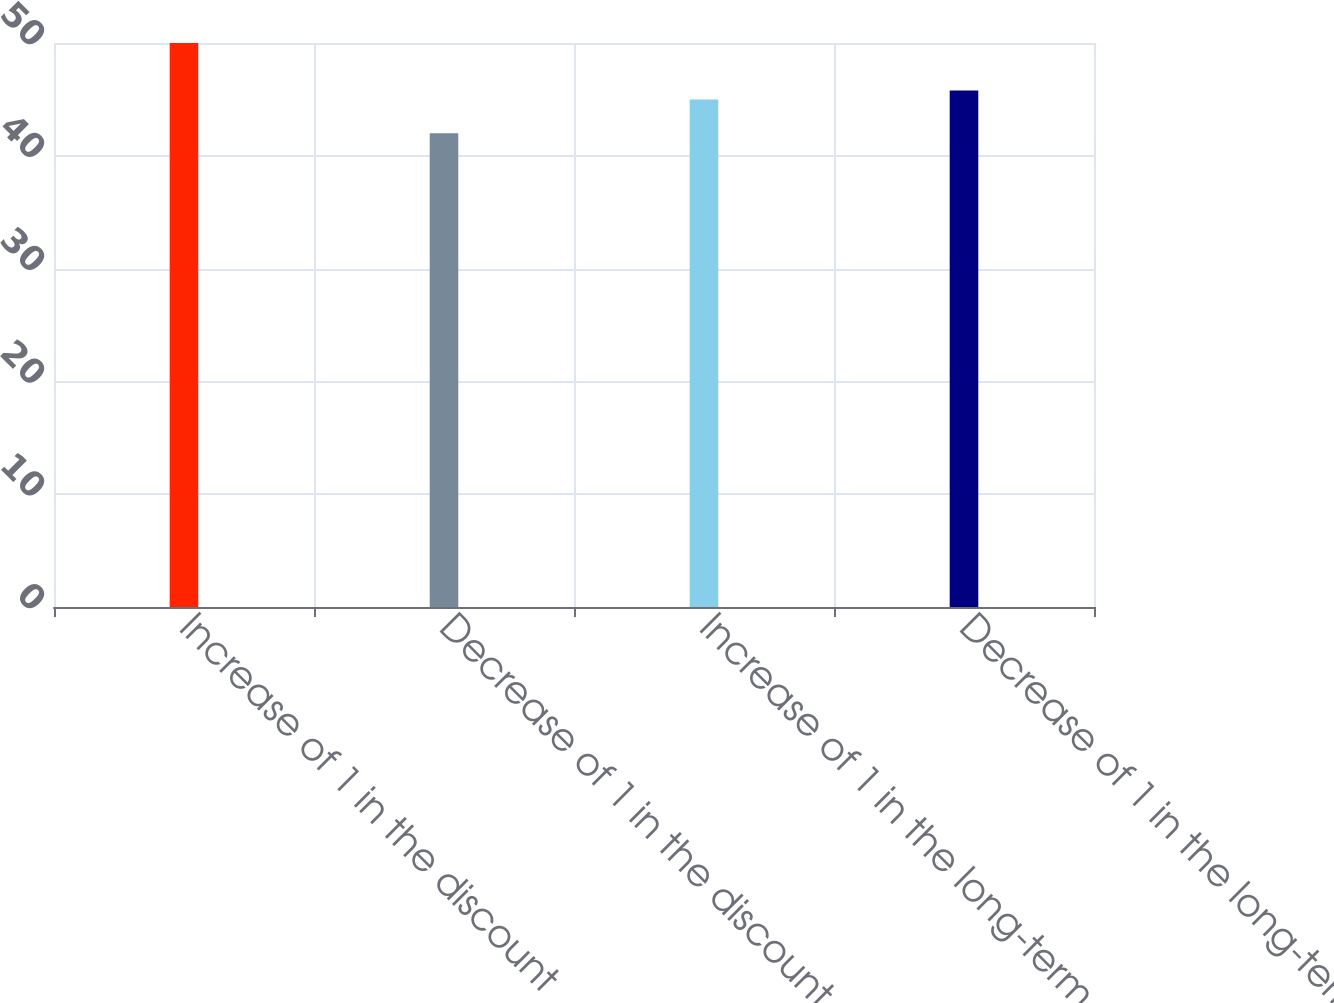<chart> <loc_0><loc_0><loc_500><loc_500><bar_chart><fcel>Increase of 1 in the discount<fcel>Decrease of 1 in the discount<fcel>Increase of 1 in the long-term<fcel>Decrease of 1 in the long-term<nl><fcel>50<fcel>42<fcel>45<fcel>45.8<nl></chart> 